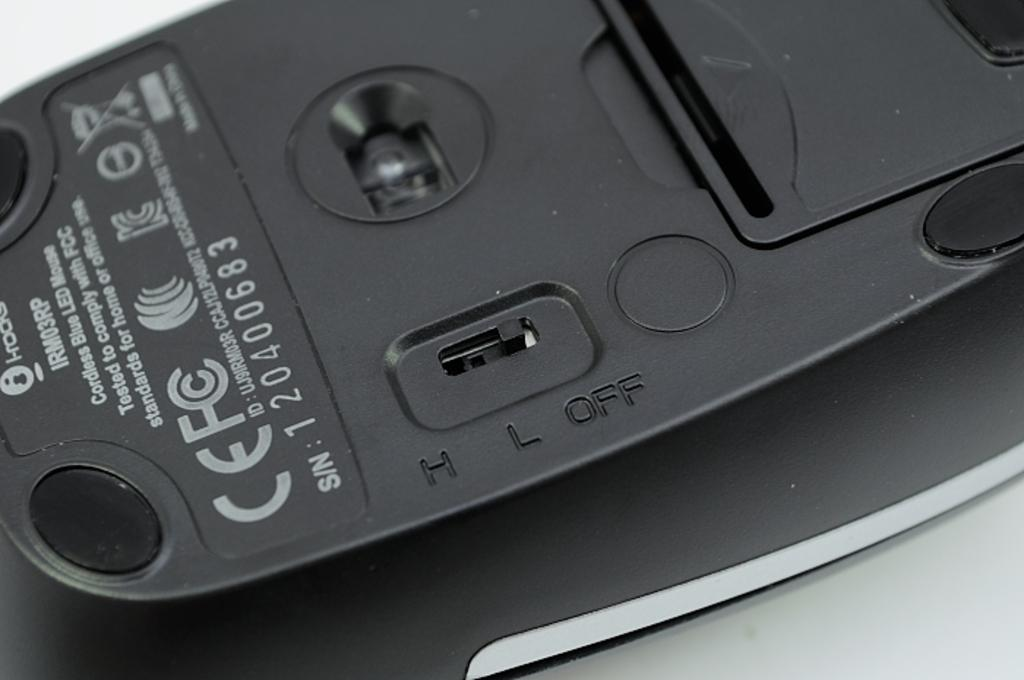Provide a one-sentence caption for the provided image. The back off the mouse where the off switch is displayed. 